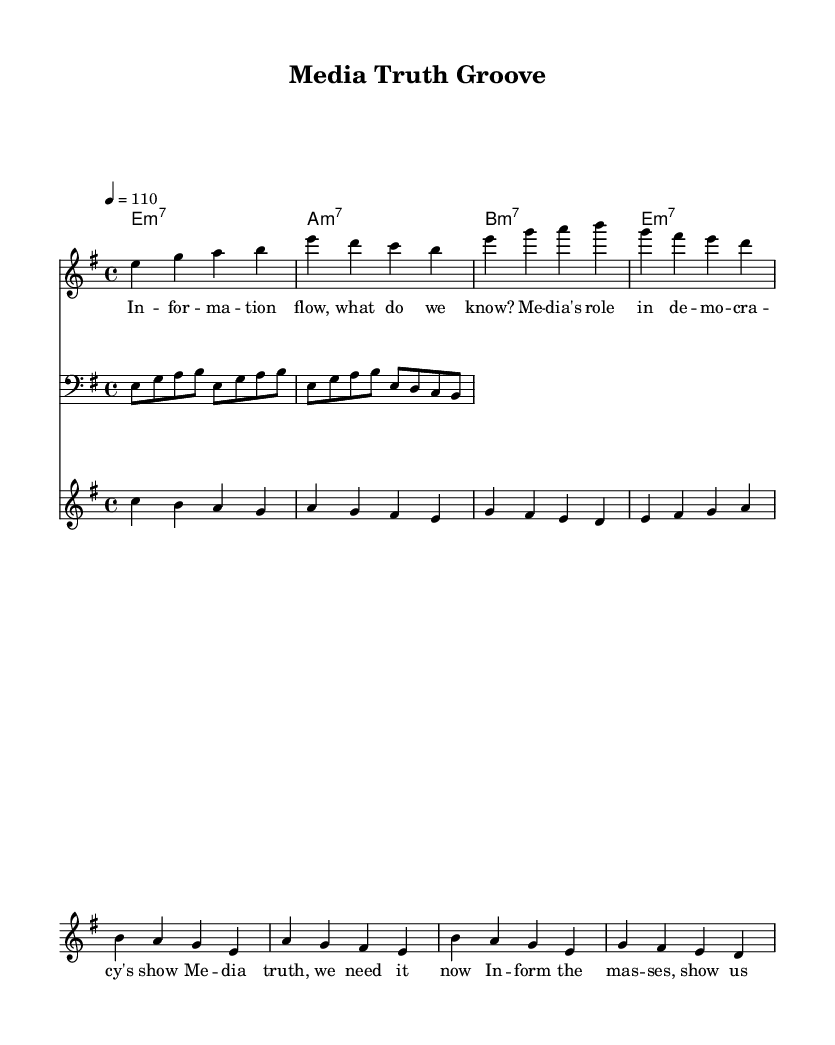What is the key signature of this music? The key signature indicated in the music shows e minor, which has one sharp (F#). This is identified by looking at the key signature section at the beginning of the score.
Answer: e minor What is the time signature of this music? The time signature is found at the beginning of the score just after the key signature. It shows 4/4, meaning there are four beats in each measure.
Answer: 4/4 What is the tempo marking for this piece? The tempo marking indicates the speed of the piece. Here, it states "4 = 110," which means it should be played at 110 beats per minute for a quarter note.
Answer: 110 How many measures are present in the main vocal section? By counting the number of times the main vocal line is written in the score, we can see that it consists of four measures for the verse and another four for the chorus. In total, that's eight measures.
Answer: 8 What chords are used in the guitar section? The guitar section indicates three different chords, which are e minor 7, a minor 7, and b minor 7. These are represented in the chord mode section of the score.
Answer: e minor 7, a minor 7, b minor 7 What is the primary theme indicated in the lyrics? The central message of the lyrics revolves around media's role in democracy and the necessity of truth in information. This can be discerned by reading through the verse and chorus lyrics presented beneath the vocal line.
Answer: Media's role in democracy 